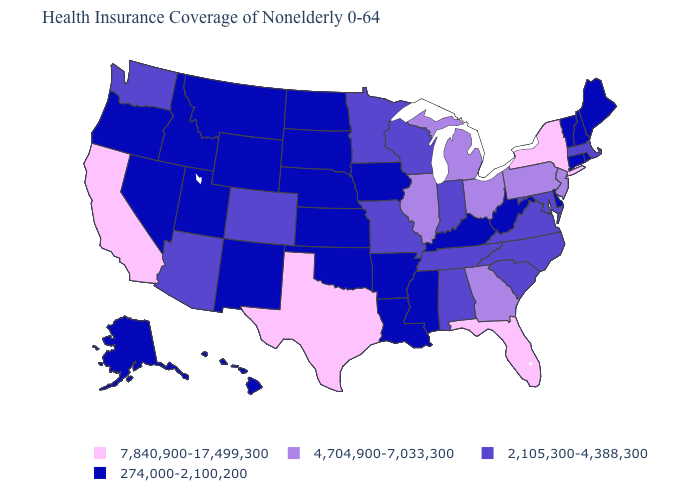Among the states that border Arkansas , which have the highest value?
Short answer required. Texas. Which states have the highest value in the USA?
Keep it brief. California, Florida, New York, Texas. Name the states that have a value in the range 2,105,300-4,388,300?
Write a very short answer. Alabama, Arizona, Colorado, Indiana, Maryland, Massachusetts, Minnesota, Missouri, North Carolina, South Carolina, Tennessee, Virginia, Washington, Wisconsin. Name the states that have a value in the range 274,000-2,100,200?
Keep it brief. Alaska, Arkansas, Connecticut, Delaware, Hawaii, Idaho, Iowa, Kansas, Kentucky, Louisiana, Maine, Mississippi, Montana, Nebraska, Nevada, New Hampshire, New Mexico, North Dakota, Oklahoma, Oregon, Rhode Island, South Dakota, Utah, Vermont, West Virginia, Wyoming. Name the states that have a value in the range 7,840,900-17,499,300?
Quick response, please. California, Florida, New York, Texas. Does North Carolina have the lowest value in the USA?
Be succinct. No. Among the states that border Alabama , which have the lowest value?
Keep it brief. Mississippi. Among the states that border Texas , which have the lowest value?
Answer briefly. Arkansas, Louisiana, New Mexico, Oklahoma. Name the states that have a value in the range 7,840,900-17,499,300?
Short answer required. California, Florida, New York, Texas. What is the value of Wisconsin?
Answer briefly. 2,105,300-4,388,300. Among the states that border Oklahoma , does Texas have the highest value?
Quick response, please. Yes. Name the states that have a value in the range 274,000-2,100,200?
Keep it brief. Alaska, Arkansas, Connecticut, Delaware, Hawaii, Idaho, Iowa, Kansas, Kentucky, Louisiana, Maine, Mississippi, Montana, Nebraska, Nevada, New Hampshire, New Mexico, North Dakota, Oklahoma, Oregon, Rhode Island, South Dakota, Utah, Vermont, West Virginia, Wyoming. Does Vermont have the lowest value in the Northeast?
Write a very short answer. Yes. Does New York have the lowest value in the Northeast?
Concise answer only. No. Does the map have missing data?
Answer briefly. No. 